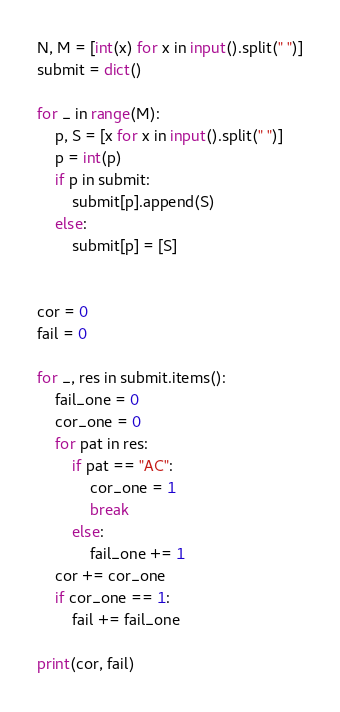Convert code to text. <code><loc_0><loc_0><loc_500><loc_500><_Python_>N, M = [int(x) for x in input().split(" ")]
submit = dict()

for _ in range(M):
    p, S = [x for x in input().split(" ")]
    p = int(p)
    if p in submit:
        submit[p].append(S)
    else:
        submit[p] = [S]


cor = 0
fail = 0

for _, res in submit.items():
    fail_one = 0
    cor_one = 0
    for pat in res:
        if pat == "AC":
            cor_one = 1
            break
        else:
            fail_one += 1
    cor += cor_one
    if cor_one == 1:
        fail += fail_one

print(cor, fail)
</code> 